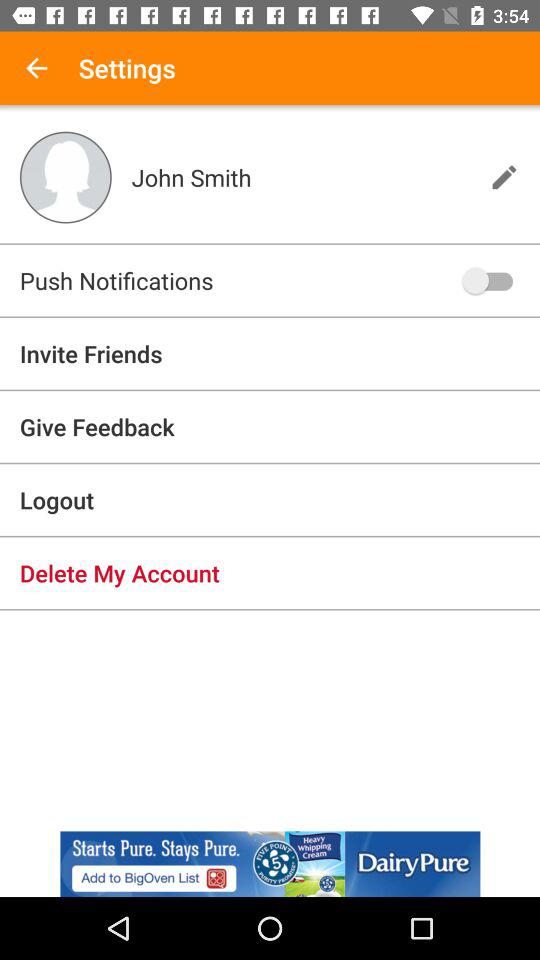What is the status of "Push Notifications"? The status is "off". 